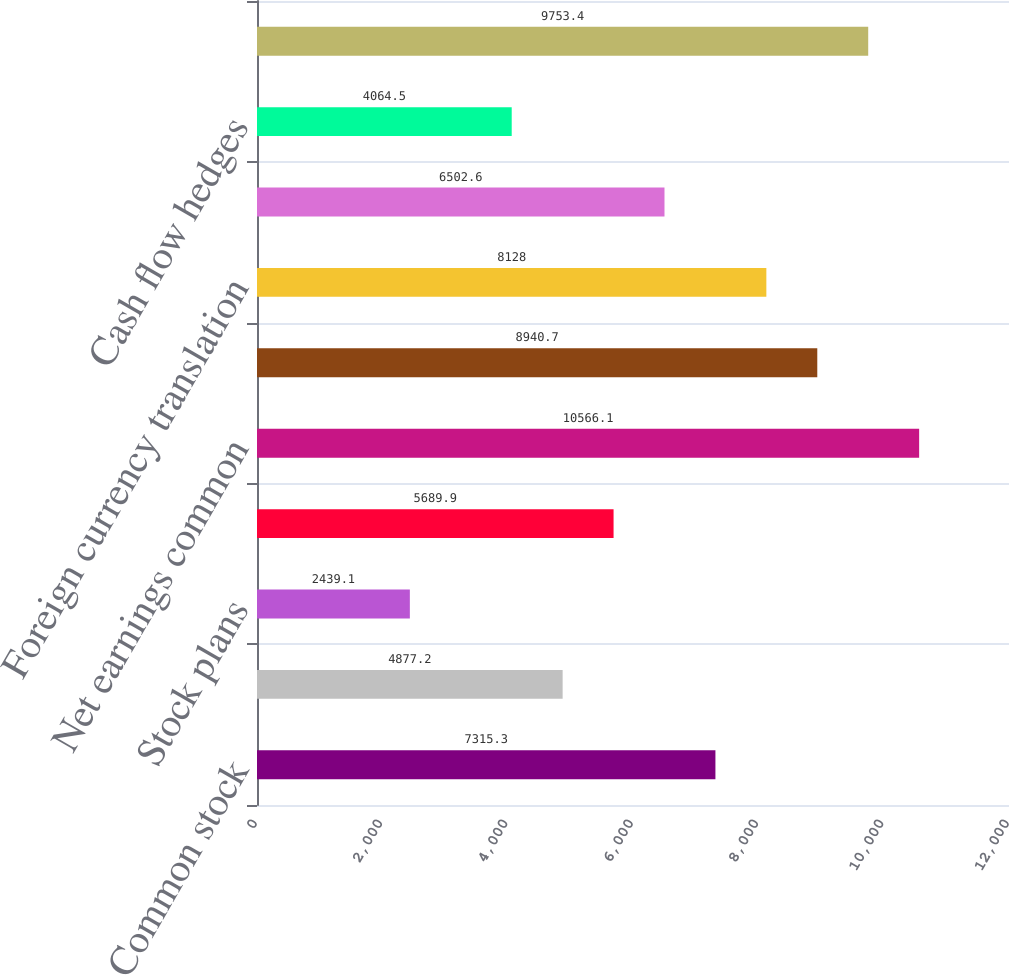<chart> <loc_0><loc_0><loc_500><loc_500><bar_chart><fcel>Common stock<fcel>Beginning balance<fcel>Stock plans<fcel>Ending balance<fcel>Net earnings common<fcel>Dividends paid (per share 2015<fcel>Foreign currency translation<fcel>Pension and postretirement<fcel>Cash flow hedges<fcel>Purchases<nl><fcel>7315.3<fcel>4877.2<fcel>2439.1<fcel>5689.9<fcel>10566.1<fcel>8940.7<fcel>8128<fcel>6502.6<fcel>4064.5<fcel>9753.4<nl></chart> 